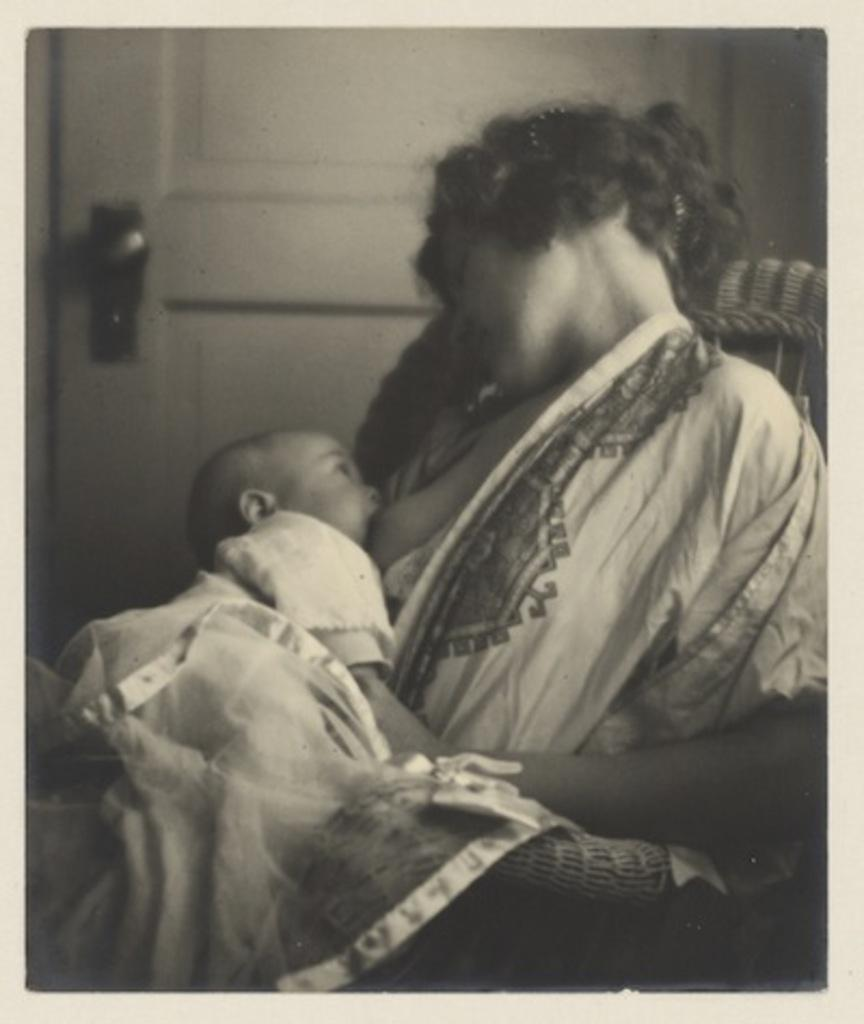Who is the main subject in the image? There is a woman in the image. What is the woman doing in the image? The woman is sitting in a chair and feeding a baby. How is the baby positioned in relation to the woman? The baby is in the woman's arms. What can be seen in the background of the image? There is a door visible in the background of the image. What month is it in the image? The month cannot be determined from the image, as there is no information about the date or time of year. What type of alarm is present in the image? There is no alarm present in the image. 